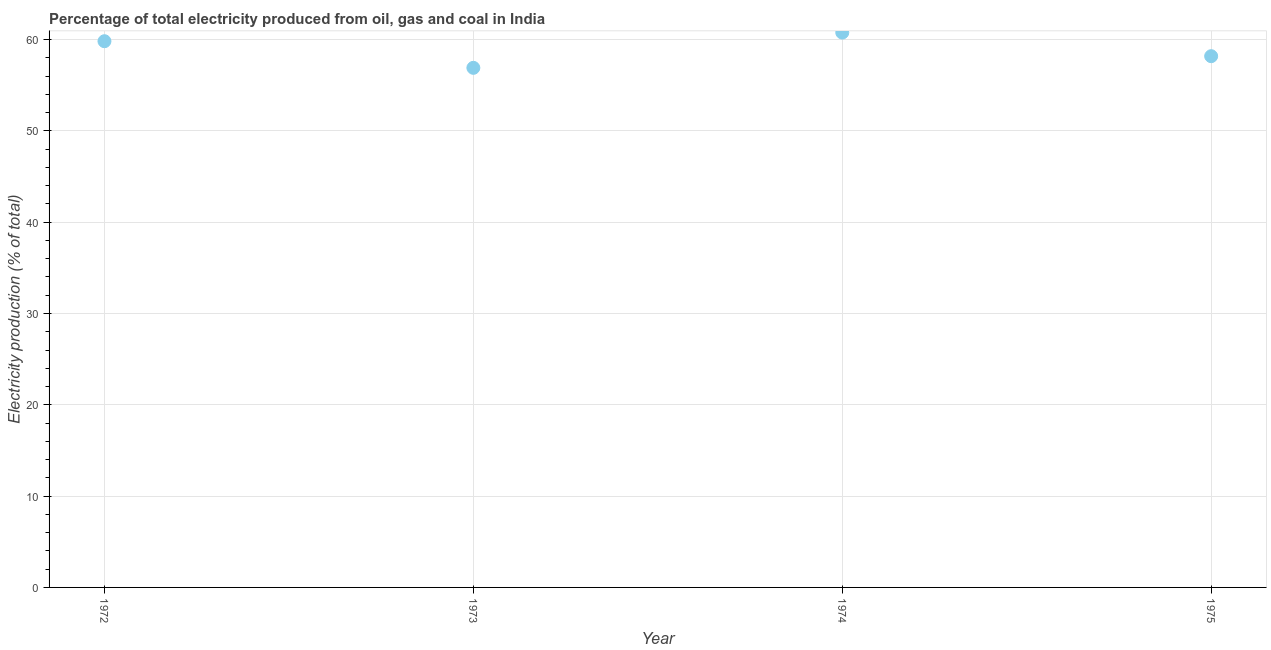What is the electricity production in 1974?
Keep it short and to the point. 60.76. Across all years, what is the maximum electricity production?
Your answer should be very brief. 60.76. Across all years, what is the minimum electricity production?
Give a very brief answer. 56.9. In which year was the electricity production maximum?
Offer a very short reply. 1974. What is the sum of the electricity production?
Make the answer very short. 235.65. What is the difference between the electricity production in 1974 and 1975?
Your answer should be very brief. 2.58. What is the average electricity production per year?
Give a very brief answer. 58.91. What is the median electricity production?
Keep it short and to the point. 59. Do a majority of the years between 1974 and 1975 (inclusive) have electricity production greater than 58 %?
Your answer should be compact. Yes. What is the ratio of the electricity production in 1972 to that in 1975?
Provide a succinct answer. 1.03. Is the electricity production in 1974 less than that in 1975?
Offer a terse response. No. What is the difference between the highest and the second highest electricity production?
Ensure brevity in your answer.  0.94. What is the difference between the highest and the lowest electricity production?
Offer a terse response. 3.86. Does the electricity production monotonically increase over the years?
Make the answer very short. No. How many dotlines are there?
Offer a terse response. 1. Are the values on the major ticks of Y-axis written in scientific E-notation?
Ensure brevity in your answer.  No. Does the graph contain any zero values?
Your answer should be very brief. No. Does the graph contain grids?
Make the answer very short. Yes. What is the title of the graph?
Offer a terse response. Percentage of total electricity produced from oil, gas and coal in India. What is the label or title of the Y-axis?
Provide a succinct answer. Electricity production (% of total). What is the Electricity production (% of total) in 1972?
Keep it short and to the point. 59.82. What is the Electricity production (% of total) in 1973?
Make the answer very short. 56.9. What is the Electricity production (% of total) in 1974?
Keep it short and to the point. 60.76. What is the Electricity production (% of total) in 1975?
Ensure brevity in your answer.  58.18. What is the difference between the Electricity production (% of total) in 1972 and 1973?
Your answer should be very brief. 2.92. What is the difference between the Electricity production (% of total) in 1972 and 1974?
Keep it short and to the point. -0.94. What is the difference between the Electricity production (% of total) in 1972 and 1975?
Give a very brief answer. 1.64. What is the difference between the Electricity production (% of total) in 1973 and 1974?
Keep it short and to the point. -3.86. What is the difference between the Electricity production (% of total) in 1973 and 1975?
Provide a short and direct response. -1.28. What is the difference between the Electricity production (% of total) in 1974 and 1975?
Give a very brief answer. 2.58. What is the ratio of the Electricity production (% of total) in 1972 to that in 1973?
Offer a terse response. 1.05. What is the ratio of the Electricity production (% of total) in 1972 to that in 1975?
Your response must be concise. 1.03. What is the ratio of the Electricity production (% of total) in 1973 to that in 1974?
Your answer should be compact. 0.94. What is the ratio of the Electricity production (% of total) in 1973 to that in 1975?
Provide a short and direct response. 0.98. What is the ratio of the Electricity production (% of total) in 1974 to that in 1975?
Your response must be concise. 1.04. 